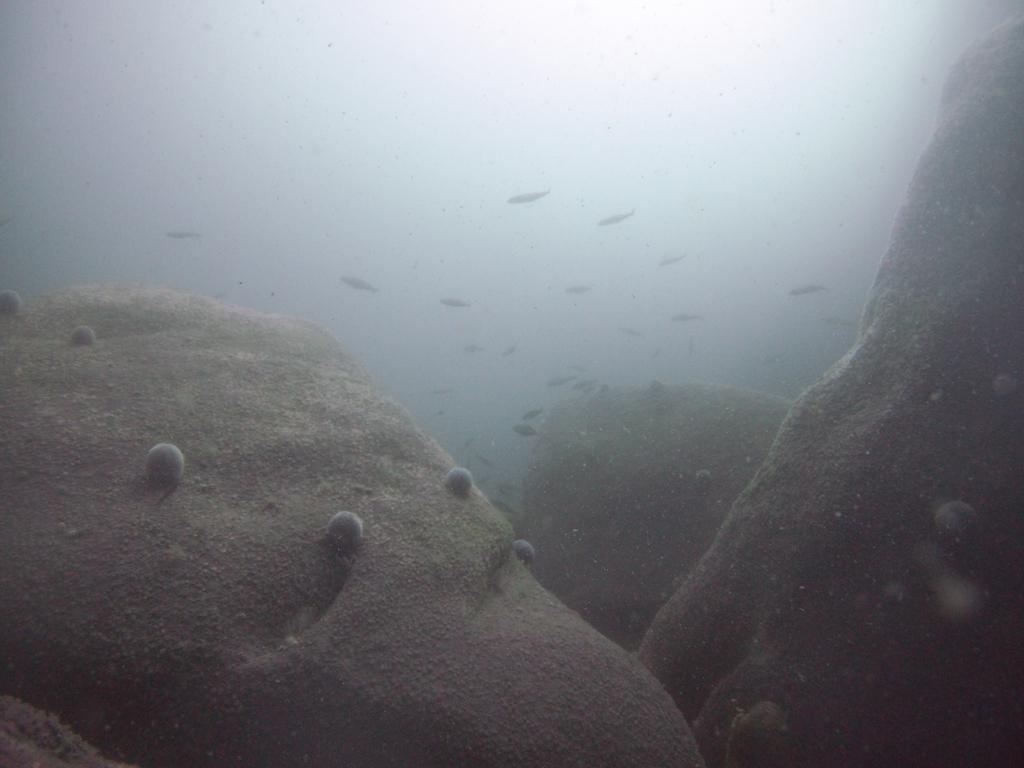What is the primary element visible in the image? There is water in the image. What type of animals can be seen in the water? There are fishes in the image. Can you see a squirrel swimming in the water in the image? No, there is no squirrel present in the image. What type of pollution can be seen in the water in the image? There is no pollution visible in the image; it only shows water and fishes. 